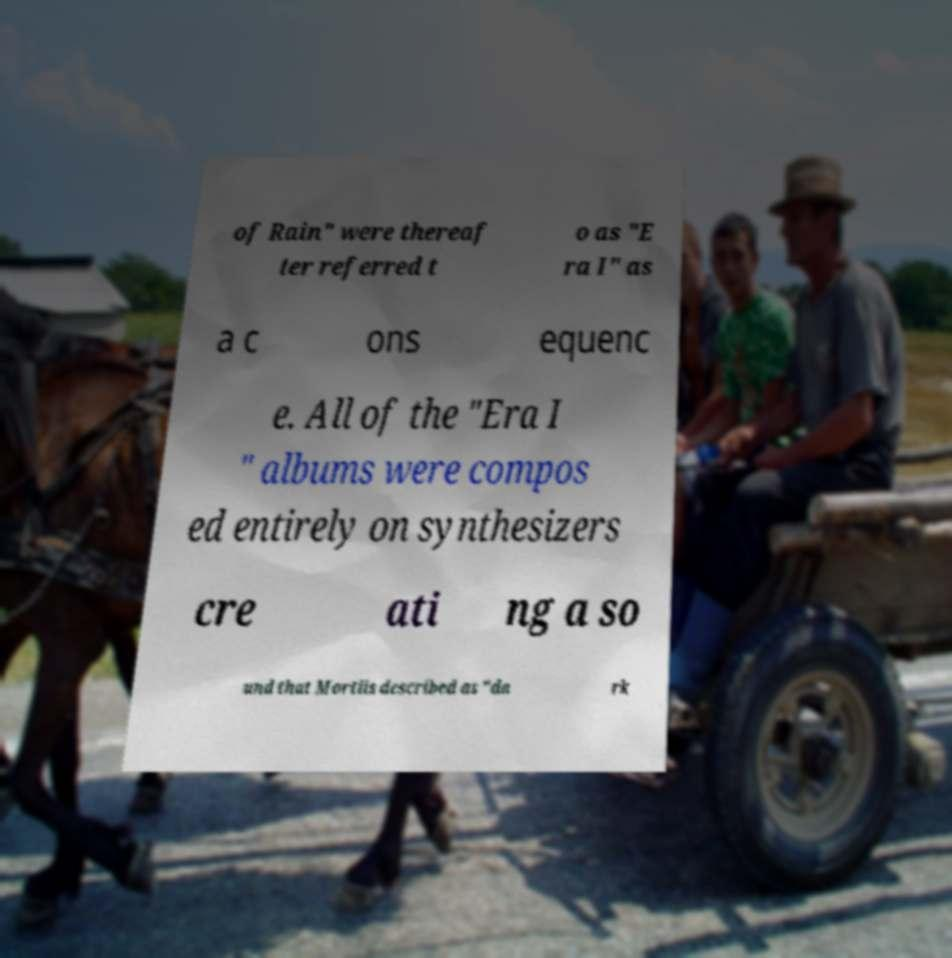Can you read and provide the text displayed in the image?This photo seems to have some interesting text. Can you extract and type it out for me? of Rain" were thereaf ter referred t o as "E ra I" as a c ons equenc e. All of the "Era I " albums were compos ed entirely on synthesizers cre ati ng a so und that Mortiis described as "da rk 